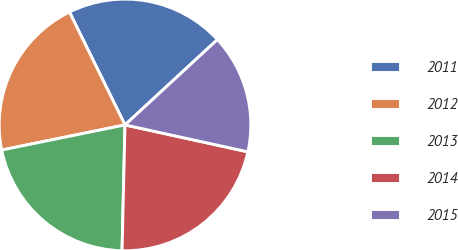Convert chart to OTSL. <chart><loc_0><loc_0><loc_500><loc_500><pie_chart><fcel>2011<fcel>2012<fcel>2013<fcel>2014<fcel>2015<nl><fcel>20.41%<fcel>20.92%<fcel>21.43%<fcel>21.94%<fcel>15.3%<nl></chart> 